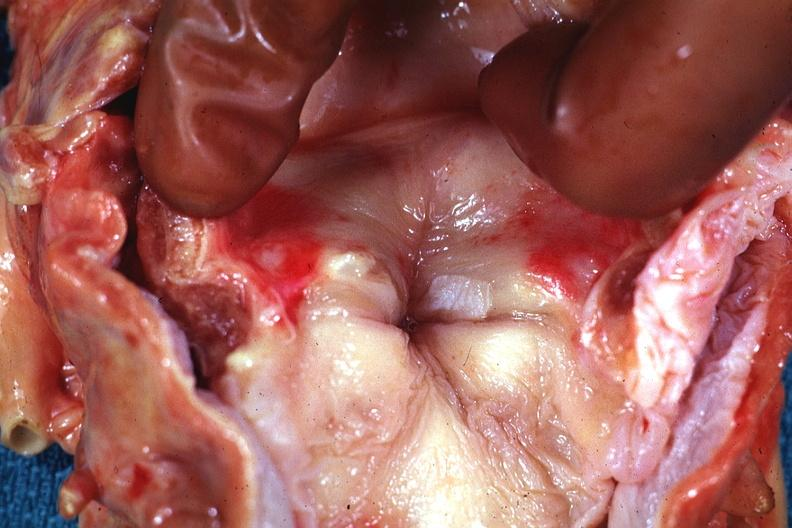does this image show shows lesion quite well in opened larynx?
Answer the question using a single word or phrase. Yes 